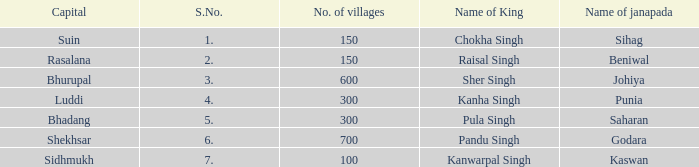What king has an S. number over 1 and a number of villages of 600? Sher Singh. Parse the full table. {'header': ['Capital', 'S.No.', 'No. of villages', 'Name of King', 'Name of janapada'], 'rows': [['Suin', '1.', '150', 'Chokha Singh', 'Sihag'], ['Rasalana', '2.', '150', 'Raisal Singh', 'Beniwal'], ['Bhurupal', '3.', '600', 'Sher Singh', 'Johiya'], ['Luddi', '4.', '300', 'Kanha Singh', 'Punia'], ['Bhadang', '5.', '300', 'Pula Singh', 'Saharan'], ['Shekhsar', '6.', '700', 'Pandu Singh', 'Godara'], ['Sidhmukh', '7.', '100', 'Kanwarpal Singh', 'Kaswan']]} 